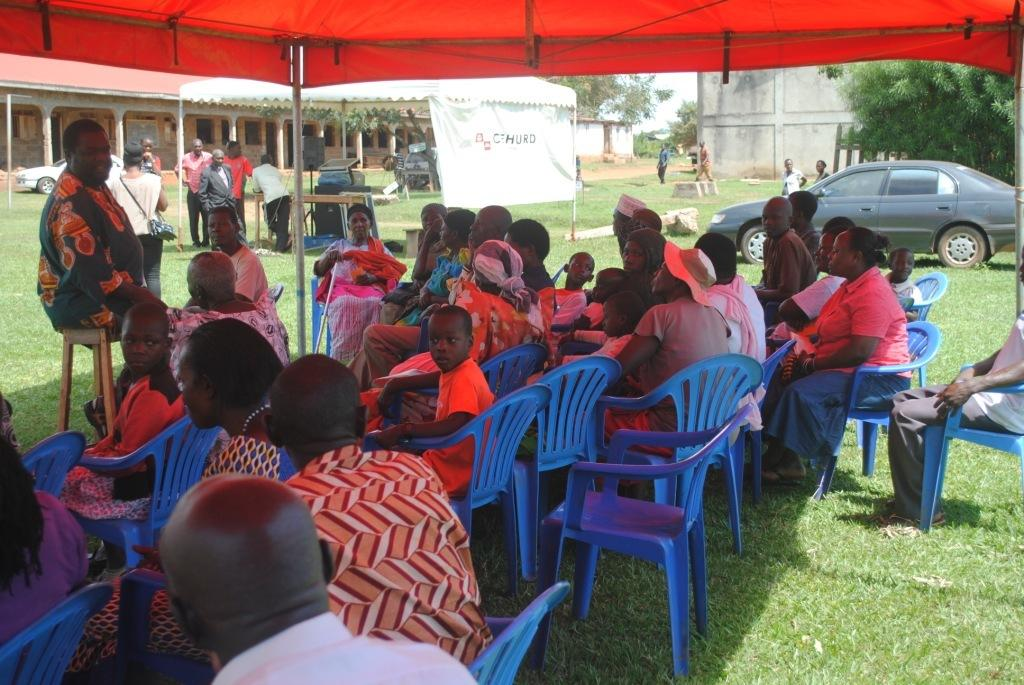How many people are in the image? There is a group of people in the image. What are the people doing in the image? The people are sitting in chairs. What can be seen in the background of the image? There is a banner, a building, a tree, grass, and a car in the background of the image. What type of cake is being served at the event depicted in the image? There is no cake present in the image; it only shows a group of people sitting in chairs with various background elements. 